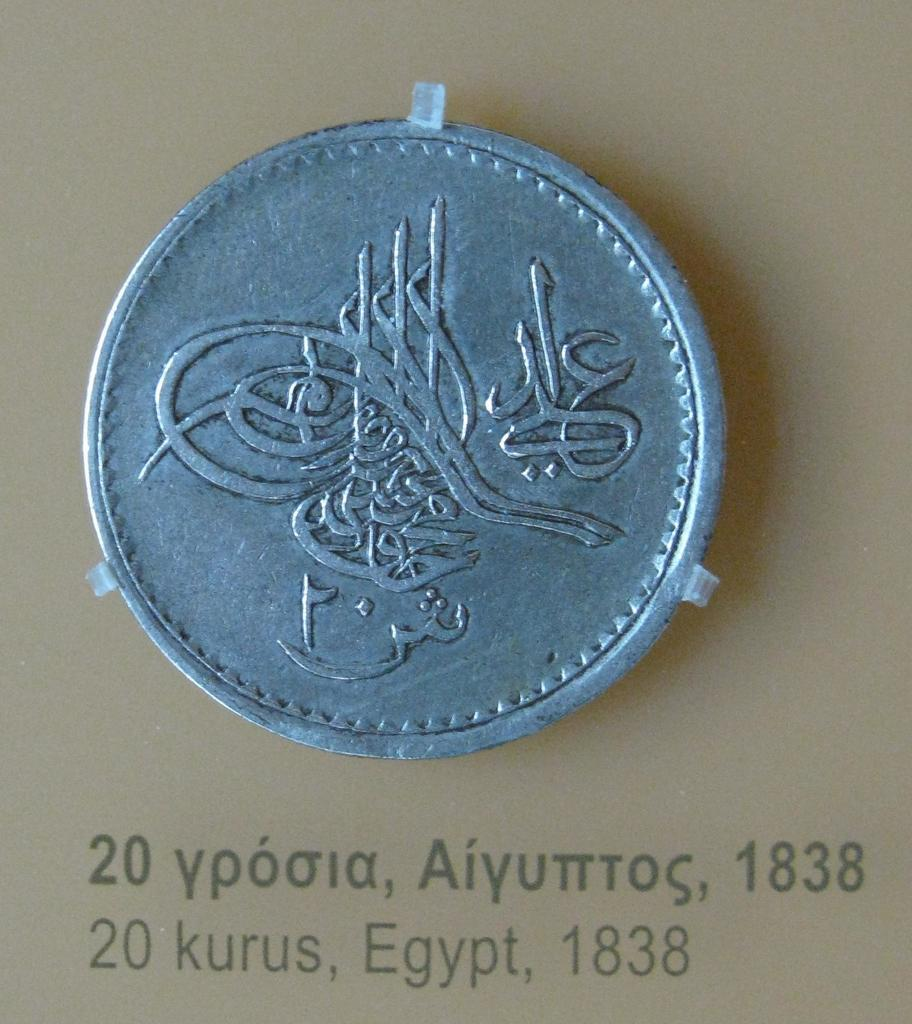<image>
Write a terse but informative summary of the picture. A closeup of a coin with the year 1838 underneath 